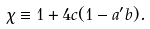Convert formula to latex. <formula><loc_0><loc_0><loc_500><loc_500>\chi \equiv 1 + 4 c ( 1 - a ^ { \prime } b ) .</formula> 